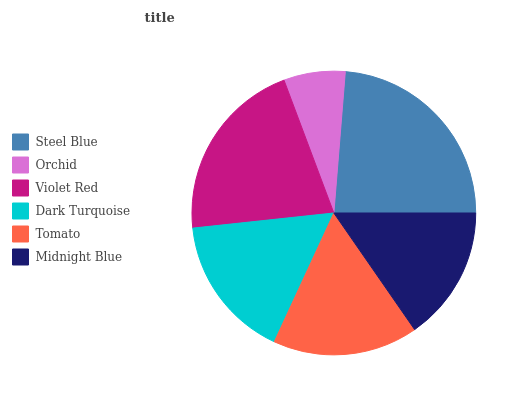Is Orchid the minimum?
Answer yes or no. Yes. Is Steel Blue the maximum?
Answer yes or no. Yes. Is Violet Red the minimum?
Answer yes or no. No. Is Violet Red the maximum?
Answer yes or no. No. Is Violet Red greater than Orchid?
Answer yes or no. Yes. Is Orchid less than Violet Red?
Answer yes or no. Yes. Is Orchid greater than Violet Red?
Answer yes or no. No. Is Violet Red less than Orchid?
Answer yes or no. No. Is Tomato the high median?
Answer yes or no. Yes. Is Dark Turquoise the low median?
Answer yes or no. Yes. Is Violet Red the high median?
Answer yes or no. No. Is Steel Blue the low median?
Answer yes or no. No. 